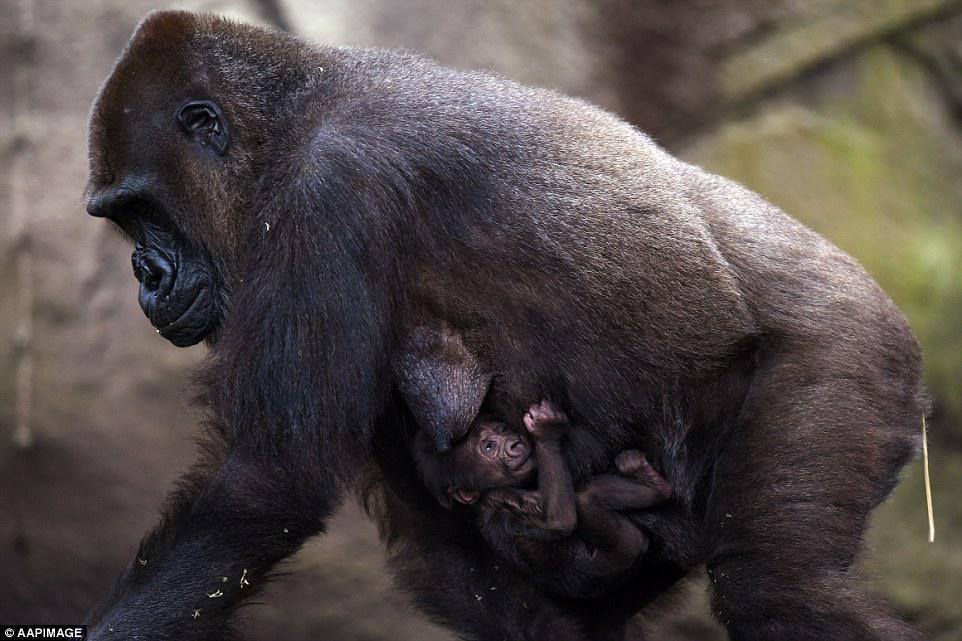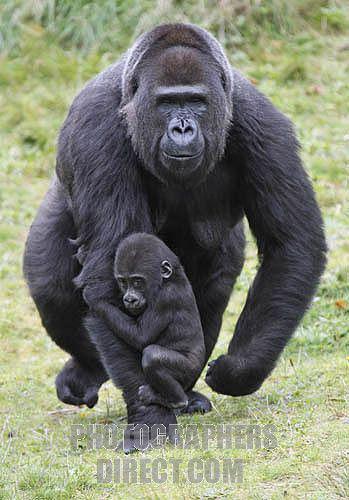The first image is the image on the left, the second image is the image on the right. Examine the images to the left and right. Is the description "At least one of the images shows an adult gorilla carrying a baby gorilla on their back, with the baby touching the adult's shoulders." accurate? Answer yes or no. No. The first image is the image on the left, the second image is the image on the right. Assess this claim about the two images: "An image shows a baby gorilla clinging on the back near the shoulders of an adult gorilla.". Correct or not? Answer yes or no. No. 